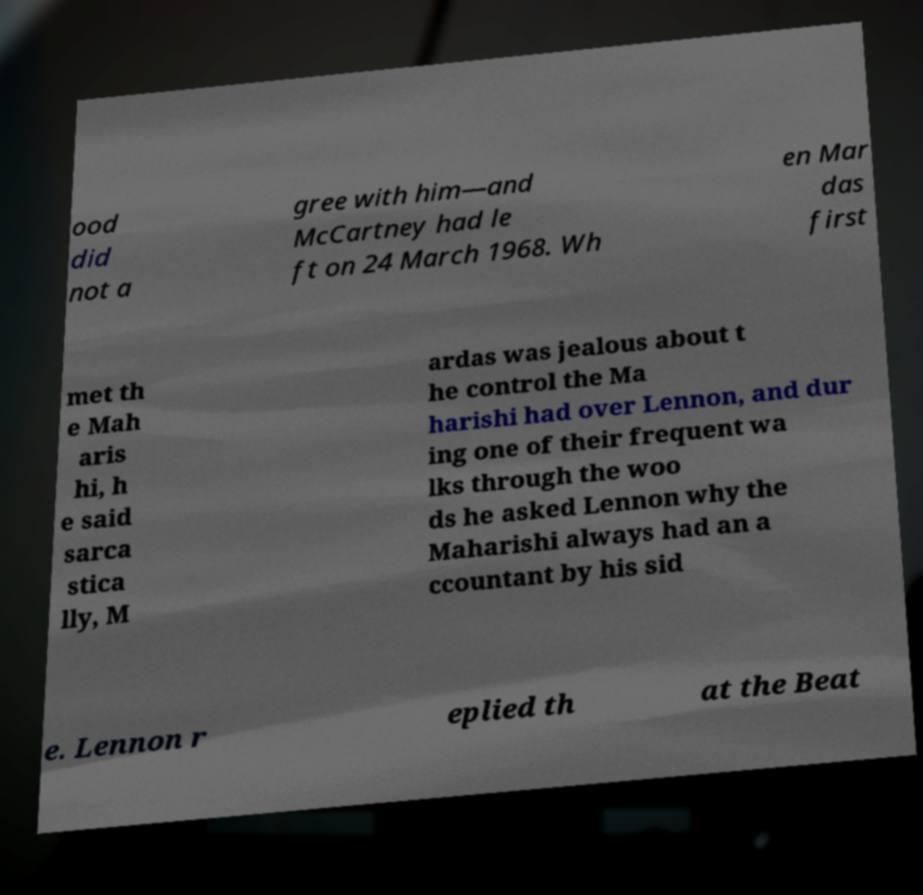I need the written content from this picture converted into text. Can you do that? ood did not a gree with him—and McCartney had le ft on 24 March 1968. Wh en Mar das first met th e Mah aris hi, h e said sarca stica lly, M ardas was jealous about t he control the Ma harishi had over Lennon, and dur ing one of their frequent wa lks through the woo ds he asked Lennon why the Maharishi always had an a ccountant by his sid e. Lennon r eplied th at the Beat 